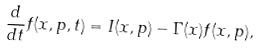<formula> <loc_0><loc_0><loc_500><loc_500>\frac { d } { d t } f ( { x } , { p } , t ) = I ( { x } , { p } ) - \Gamma ( { x } ) f ( { x } , { p } ) ,</formula> 